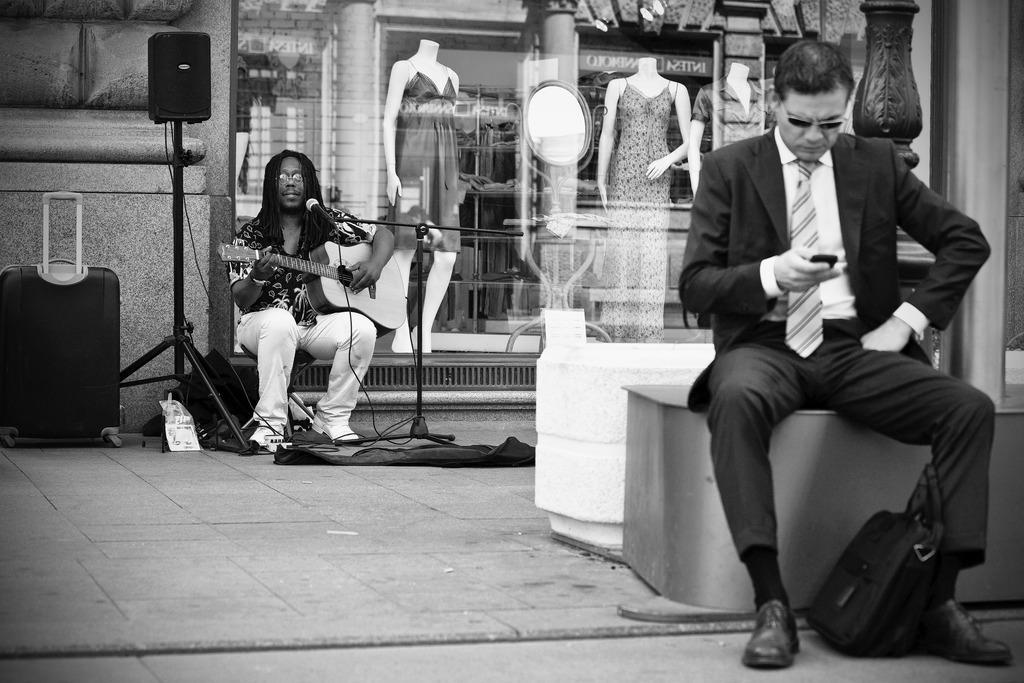In one or two sentences, can you explain what this image depicts? There is a man sitting and playing guitar in a micro phone and there is a briefcase on left and a marquee on right. just opposite to him there is other man sitting and holding bag and operating cell phone. 